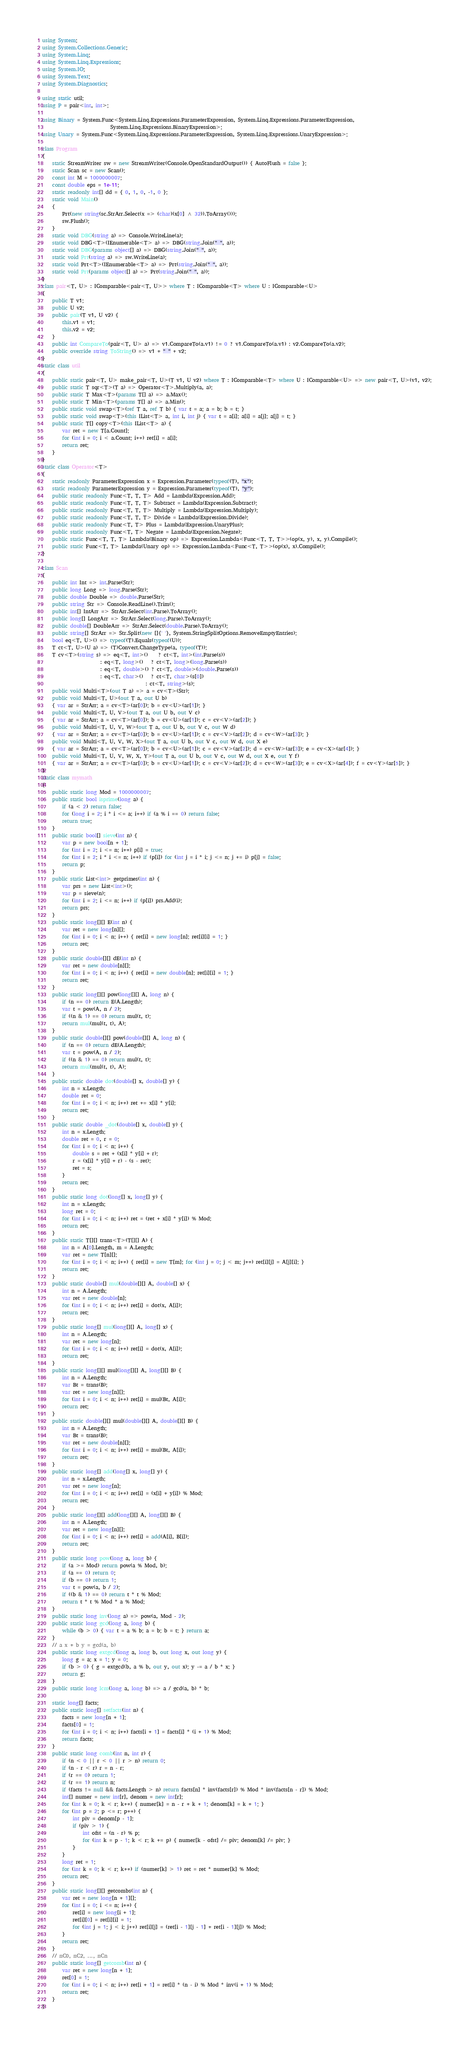<code> <loc_0><loc_0><loc_500><loc_500><_C#_>using System;
using System.Collections.Generic;
using System.Linq;
using System.Linq.Expressions;
using System.IO;
using System.Text;
using System.Diagnostics;

using static util;
using P = pair<int, int>;

using Binary = System.Func<System.Linq.Expressions.ParameterExpression, System.Linq.Expressions.ParameterExpression,
                           System.Linq.Expressions.BinaryExpression>;
using Unary = System.Func<System.Linq.Expressions.ParameterExpression, System.Linq.Expressions.UnaryExpression>;

class Program
{
    static StreamWriter sw = new StreamWriter(Console.OpenStandardOutput()) { AutoFlush = false };
    static Scan sc = new Scan();
    const int M = 1000000007;
    const double eps = 1e-11;
    static readonly int[] dd = { 0, 1, 0, -1, 0 };
    static void Main()
    {
        Prt(new string(sc.StrArr.Select(x => (char)(x[0] ^ 32)).ToArray()));
        sw.Flush();
    }
    static void DBG(string a) => Console.WriteLine(a);
    static void DBG<T>(IEnumerable<T> a) => DBG(string.Join(" ", a));
    static void DBG(params object[] a) => DBG(string.Join(" ", a));
    static void Prt(string a) => sw.WriteLine(a);
    static void Prt<T>(IEnumerable<T> a) => Prt(string.Join(" ", a));
    static void Prt(params object[] a) => Prt(string.Join(" ", a));
}
class pair<T, U> : IComparable<pair<T, U>> where T : IComparable<T> where U : IComparable<U>
{
    public T v1;
    public U v2;
    public pair(T v1, U v2) {
        this.v1 = v1;
        this.v2 = v2;
    }
    public int CompareTo(pair<T, U> a) => v1.CompareTo(a.v1) != 0 ? v1.CompareTo(a.v1) : v2.CompareTo(a.v2);
    public override string ToString() => v1 + " " + v2;
}
static class util
{
    public static pair<T, U> make_pair<T, U>(T v1, U v2) where T : IComparable<T> where U : IComparable<U> => new pair<T, U>(v1, v2);
    public static T sqr<T>(T a) => Operator<T>.Multiply(a, a);
    public static T Max<T>(params T[] a) => a.Max();
    public static T Min<T>(params T[] a) => a.Min();
    public static void swap<T>(ref T a, ref T b) { var t = a; a = b; b = t; }
    public static void swap<T>(this IList<T> a, int i, int j) { var t = a[i]; a[i] = a[j]; a[j] = t; }
    public static T[] copy<T>(this IList<T> a) {
        var ret = new T[a.Count];
        for (int i = 0; i < a.Count; i++) ret[i] = a[i];
        return ret;
    }
}
static class Operator<T>
{
    static readonly ParameterExpression x = Expression.Parameter(typeof(T), "x");
    static readonly ParameterExpression y = Expression.Parameter(typeof(T), "y");
    public static readonly Func<T, T, T> Add = Lambda(Expression.Add);
    public static readonly Func<T, T, T> Subtract = Lambda(Expression.Subtract);
    public static readonly Func<T, T, T> Multiply = Lambda(Expression.Multiply);
    public static readonly Func<T, T, T> Divide = Lambda(Expression.Divide);
    public static readonly Func<T, T> Plus = Lambda(Expression.UnaryPlus);
    public static readonly Func<T, T> Negate = Lambda(Expression.Negate);
    public static Func<T, T, T> Lambda(Binary op) => Expression.Lambda<Func<T, T, T>>(op(x, y), x, y).Compile();
    public static Func<T, T> Lambda(Unary op) => Expression.Lambda<Func<T, T>>(op(x), x).Compile();
}

class Scan
{
    public int Int => int.Parse(Str);
    public long Long => long.Parse(Str);
    public double Double => double.Parse(Str);
    public string Str => Console.ReadLine().Trim();
    public int[] IntArr => StrArr.Select(int.Parse).ToArray();
    public long[] LongArr => StrArr.Select(long.Parse).ToArray();
    public double[] DoubleArr => StrArr.Select(double.Parse).ToArray();
    public string[] StrArr => Str.Split(new []{' '}, System.StringSplitOptions.RemoveEmptyEntries);
    bool eq<T, U>() => typeof(T).Equals(typeof(U));
    T ct<T, U>(U a) => (T)Convert.ChangeType(a, typeof(T));
    T cv<T>(string s) => eq<T, int>()    ? ct<T, int>(int.Parse(s))
                       : eq<T, long>()   ? ct<T, long>(long.Parse(s))
                       : eq<T, double>() ? ct<T, double>(double.Parse(s))
                       : eq<T, char>()   ? ct<T, char>(s[0])
                                         : ct<T, string>(s);
    public void Multi<T>(out T a) => a = cv<T>(Str);
    public void Multi<T, U>(out T a, out U b)
    { var ar = StrArr; a = cv<T>(ar[0]); b = cv<U>(ar[1]); }
    public void Multi<T, U, V>(out T a, out U b, out V c)
    { var ar = StrArr; a = cv<T>(ar[0]); b = cv<U>(ar[1]); c = cv<V>(ar[2]); }
    public void Multi<T, U, V, W>(out T a, out U b, out V c, out W d)
    { var ar = StrArr; a = cv<T>(ar[0]); b = cv<U>(ar[1]); c = cv<V>(ar[2]); d = cv<W>(ar[3]); }
    public void Multi<T, U, V, W, X>(out T a, out U b, out V c, out W d, out X e)
    { var ar = StrArr; a = cv<T>(ar[0]); b = cv<U>(ar[1]); c = cv<V>(ar[2]); d = cv<W>(ar[3]); e = cv<X>(ar[4]); }
    public void Multi<T, U, V, W, X, Y>(out T a, out U b, out V c, out W d, out X e, out Y f)
    { var ar = StrArr; a = cv<T>(ar[0]); b = cv<U>(ar[1]); c = cv<V>(ar[2]); d = cv<W>(ar[3]); e = cv<X>(ar[4]); f = cv<Y>(ar[5]); }
}
static class mymath
{
    public static long Mod = 1000000007;
    public static bool isprime(long a) {
        if (a < 2) return false;
        for (long i = 2; i * i <= a; i++) if (a % i == 0) return false;
        return true;
    }
    public static bool[] sieve(int n) {
        var p = new bool[n + 1];
        for (int i = 2; i <= n; i++) p[i] = true;
        for (int i = 2; i * i <= n; i++) if (p[i]) for (int j = i * i; j <= n; j += i) p[j] = false;
        return p;
    }
    public static List<int> getprimes(int n) {
        var prs = new List<int>();
        var p = sieve(n);
        for (int i = 2; i <= n; i++) if (p[i]) prs.Add(i);
        return prs;
    }
    public static long[][] E(int n) {
        var ret = new long[n][];
        for (int i = 0; i < n; i++) { ret[i] = new long[n]; ret[i][i] = 1; }
        return ret;
    }
    public static double[][] dE(int n) {
        var ret = new double[n][];
        for (int i = 0; i < n; i++) { ret[i] = new double[n]; ret[i][i] = 1; }
        return ret;
    }
    public static long[][] pow(long[][] A, long n) {
        if (n == 0) return E(A.Length);
        var t = pow(A, n / 2);
        if ((n & 1) == 0) return mul(t, t);
        return mul(mul(t, t), A);
    }
    public static double[][] pow(double[][] A, long n) {
        if (n == 0) return dE(A.Length);
        var t = pow(A, n / 2);
        if ((n & 1) == 0) return mul(t, t);
        return mul(mul(t, t), A);
    }
    public static double dot(double[] x, double[] y) {
        int n = x.Length;
        double ret = 0;
        for (int i = 0; i < n; i++) ret += x[i] * y[i];
        return ret;
    }
    public static double _dot(double[] x, double[] y) {
        int n = x.Length;
        double ret = 0, r = 0;
        for (int i = 0; i < n; i++) {
            double s = ret + (x[i] * y[i] + r);
            r = (x[i] * y[i] + r) - (s - ret);
            ret = s;
        }
        return ret;
    }
    public static long dot(long[] x, long[] y) {
        int n = x.Length;
        long ret = 0;
        for (int i = 0; i < n; i++) ret = (ret + x[i] * y[i]) % Mod;
        return ret;
    }
    public static T[][] trans<T>(T[][] A) {
        int n = A[0].Length, m = A.Length;
        var ret = new T[n][];
        for (int i = 0; i < n; i++) { ret[i] = new T[m]; for (int j = 0; j < m; j++) ret[i][j] = A[j][i]; }
        return ret;
    }
    public static double[] mul(double[][] A, double[] x) {
        int n = A.Length;
        var ret = new double[n];
        for (int i = 0; i < n; i++) ret[i] = dot(x, A[i]);
        return ret;
    }
    public static long[] mul(long[][] A, long[] x) {
        int n = A.Length;
        var ret = new long[n];
        for (int i = 0; i < n; i++) ret[i] = dot(x, A[i]);
        return ret;
    }
    public static long[][] mul(long[][] A, long[][] B) {
        int n = A.Length;
        var Bt = trans(B);
        var ret = new long[n][];
        for (int i = 0; i < n; i++) ret[i] = mul(Bt, A[i]);
        return ret;
    }
    public static double[][] mul(double[][] A, double[][] B) {
        int n = A.Length;
        var Bt = trans(B);
        var ret = new double[n][];
        for (int i = 0; i < n; i++) ret[i] = mul(Bt, A[i]);
        return ret;
    }
    public static long[] add(long[] x, long[] y) {
        int n = x.Length;
        var ret = new long[n];
        for (int i = 0; i < n; i++) ret[i] = (x[i] + y[i]) % Mod;
        return ret;
    }
    public static long[][] add(long[][] A, long[][] B) {
        int n = A.Length;
        var ret = new long[n][];
        for (int i = 0; i < n; i++) ret[i] = add(A[i], B[i]);
        return ret;
    }
    public static long pow(long a, long b) {
        if (a >= Mod) return pow(a % Mod, b);
        if (a == 0) return 0;
        if (b == 0) return 1;
        var t = pow(a, b / 2);
        if ((b & 1) == 0) return t * t % Mod;
        return t * t % Mod * a % Mod;
    }
    public static long inv(long a) => pow(a, Mod - 2);
    public static long gcd(long a, long b) {
        while (b > 0) { var t = a % b; a = b; b = t; } return a;
    }
    // a x + b y = gcd(a, b)
    public static long extgcd(long a, long b, out long x, out long y) {
        long g = a; x = 1; y = 0;
        if (b > 0) { g = extgcd(b, a % b, out y, out x); y -= a / b * x; }
        return g;
    }
    public static long lcm(long a, long b) => a / gcd(a, b) * b;

    static long[] facts;
    public static long[] setfacts(int n) {
        facts = new long[n + 1];
        facts[0] = 1;
        for (int i = 0; i < n; i++) facts[i + 1] = facts[i] * (i + 1) % Mod;
        return facts;
    }
    public static long comb(int n, int r) {
        if (n < 0 || r < 0 || r > n) return 0;
        if (n - r < r) r = n - r;
        if (r == 0) return 1;
        if (r == 1) return n;
        if (facts != null && facts.Length > n) return facts[n] * inv(facts[r]) % Mod * inv(facts[n - r]) % Mod;
        int[] numer = new int[r], denom = new int[r];
        for (int k = 0; k < r; k++) { numer[k] = n - r + k + 1; denom[k] = k + 1; }
        for (int p = 2; p <= r; p++) {
            int piv = denom[p - 1];
            if (piv > 1) {
                int ofst = (n - r) % p;
                for (int k = p - 1; k < r; k += p) { numer[k - ofst] /= piv; denom[k] /= piv; }
            }
        }
        long ret = 1;
        for (int k = 0; k < r; k++) if (numer[k] > 1) ret = ret * numer[k] % Mod;
        return ret;
    }
    public static long[][] getcombs(int n) {
        var ret = new long[n + 1][];
        for (int i = 0; i <= n; i++) {
            ret[i] = new long[i + 1];
            ret[i][0] = ret[i][i] = 1;
            for (int j = 1; j < i; j++) ret[i][j] = (ret[i - 1][j - 1] + ret[i - 1][j]) % Mod;
        }
        return ret;
    }
    // nC0, nC2, ..., nCn
    public static long[] getcomb(int n) {
        var ret = new long[n + 1];
        ret[0] = 1;
        for (int i = 0; i < n; i++) ret[i + 1] = ret[i] * (n - i) % Mod * inv(i + 1) % Mod;
        return ret;
    }
}
</code> 